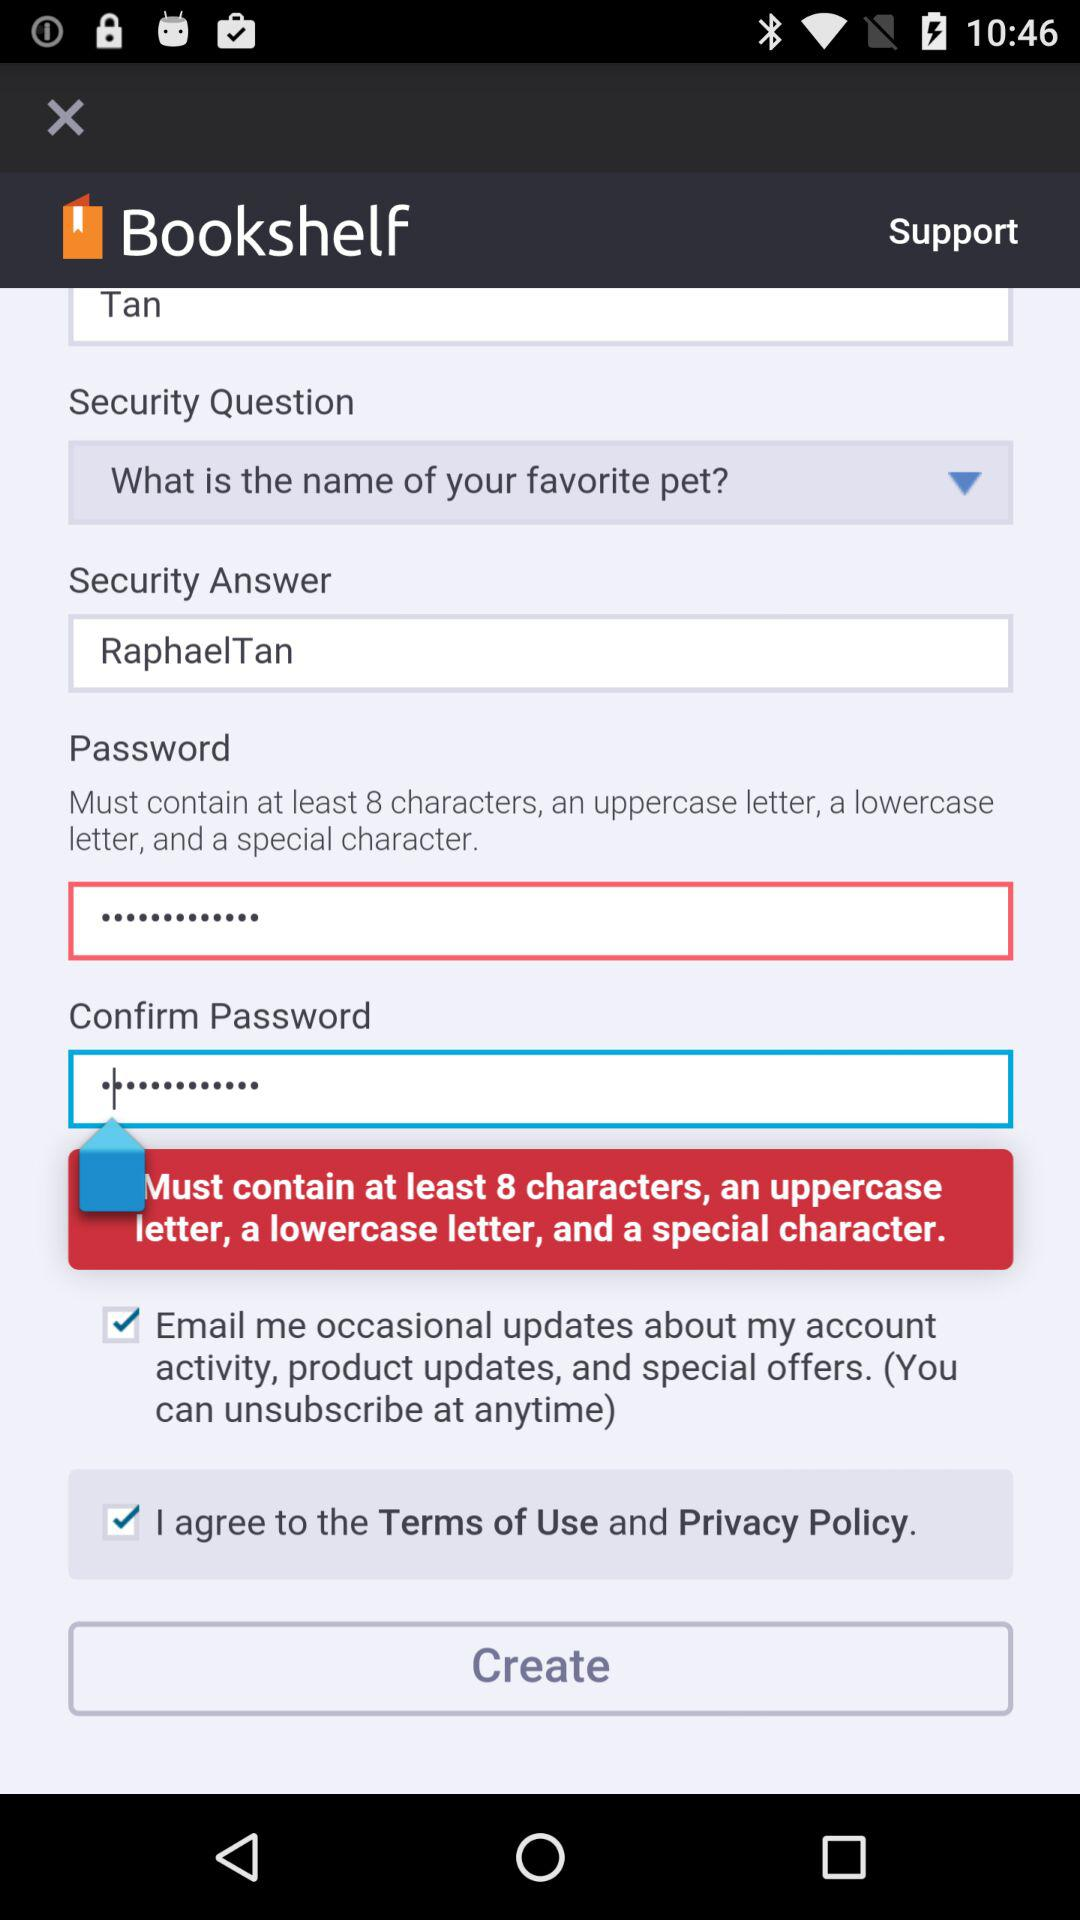Which options are available for contacting support?
When the provided information is insufficient, respond with <no answer>. <no answer> 